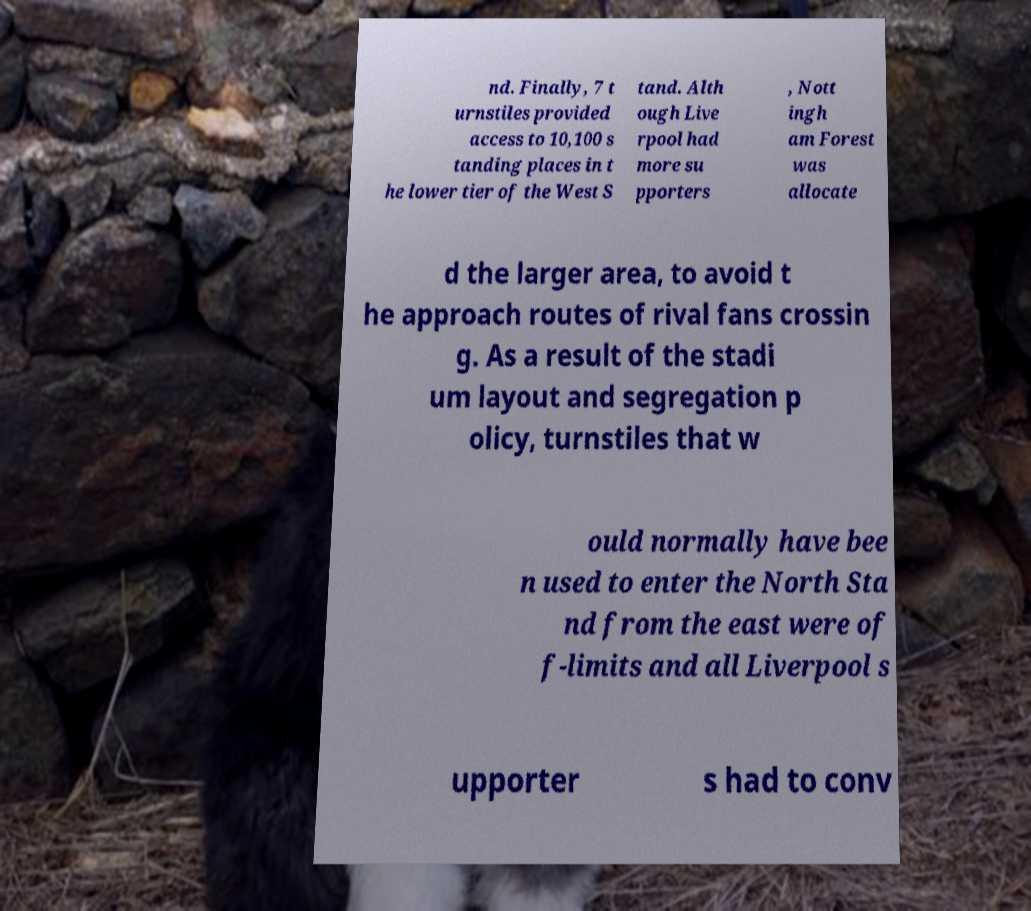Could you extract and type out the text from this image? nd. Finally, 7 t urnstiles provided access to 10,100 s tanding places in t he lower tier of the West S tand. Alth ough Live rpool had more su pporters , Nott ingh am Forest was allocate d the larger area, to avoid t he approach routes of rival fans crossin g. As a result of the stadi um layout and segregation p olicy, turnstiles that w ould normally have bee n used to enter the North Sta nd from the east were of f-limits and all Liverpool s upporter s had to conv 